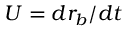Convert formula to latex. <formula><loc_0><loc_0><loc_500><loc_500>U = d r _ { b } / d t</formula> 